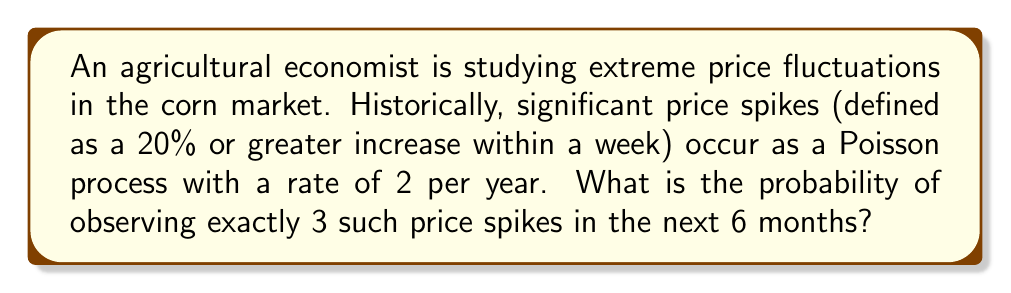Solve this math problem. To solve this problem, we'll use the Poisson distribution formula:

$$P(X = k) = \frac{e^{-\lambda} \lambda^k}{k!}$$

Where:
- $X$ is the number of events
- $k$ is the specific number of events we're interested in
- $\lambda$ is the average number of events in the given time period

Step 1: Determine $\lambda$ for the 6-month period
- Given rate: 2 price spikes per year
- Time period: 6 months = 0.5 years
- $\lambda = 2 \times 0.5 = 1$

Step 2: Apply the Poisson distribution formula with $k = 3$ and $\lambda = 1$

$$P(X = 3) = \frac{e^{-1} 1^3}{3!}$$

Step 3: Simplify
$$P(X = 3) = \frac{e^{-1} \times 1}{6}$$

Step 4: Calculate
$$P(X = 3) = \frac{0.3679}{6} \approx 0.0613$$

Therefore, the probability of observing exactly 3 significant price spikes in the next 6 months is approximately 0.0613 or 6.13%.
Answer: 0.0613 